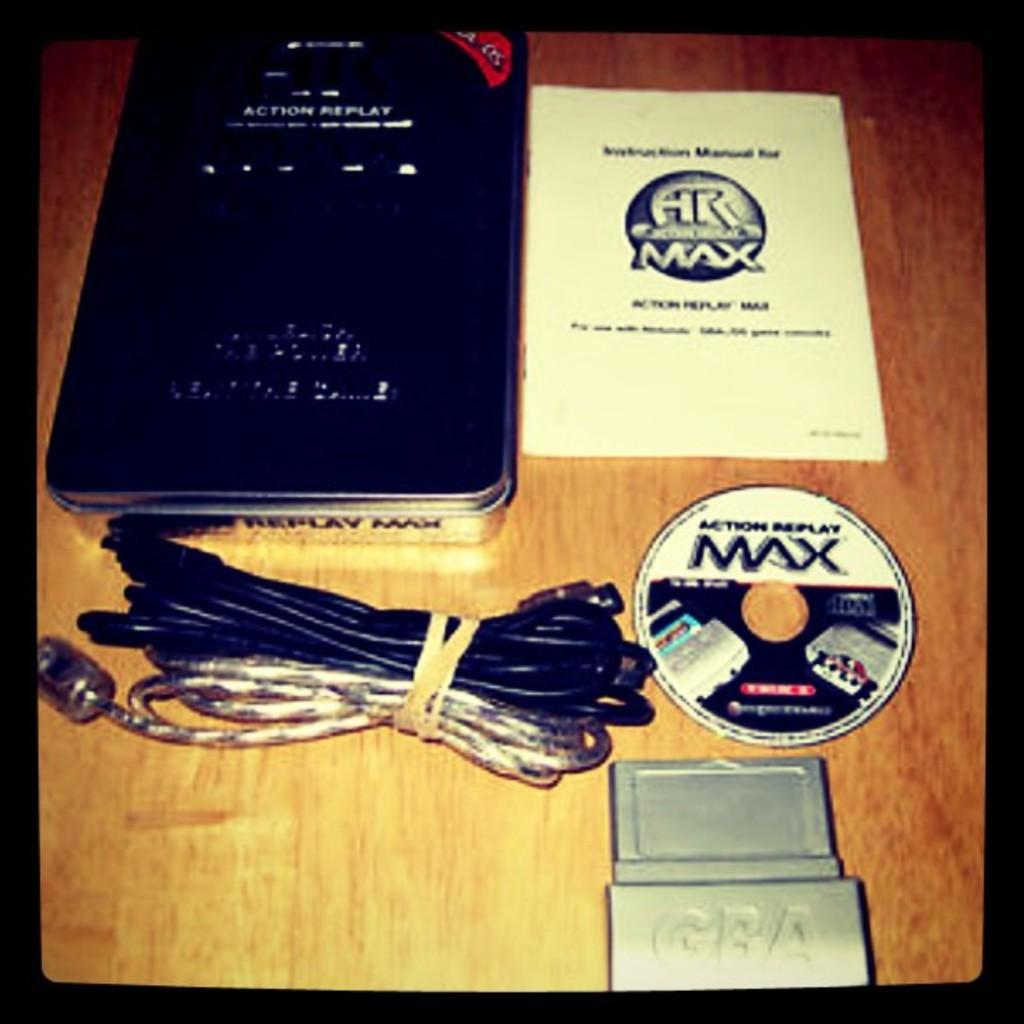Provide a one-sentence caption for the provided image. A "Max" brand CD with case and cords. 